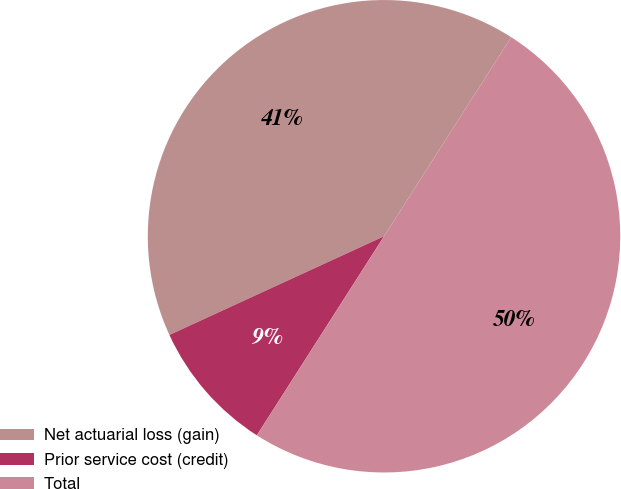Convert chart. <chart><loc_0><loc_0><loc_500><loc_500><pie_chart><fcel>Net actuarial loss (gain)<fcel>Prior service cost (credit)<fcel>Total<nl><fcel>40.91%<fcel>9.09%<fcel>50.0%<nl></chart> 